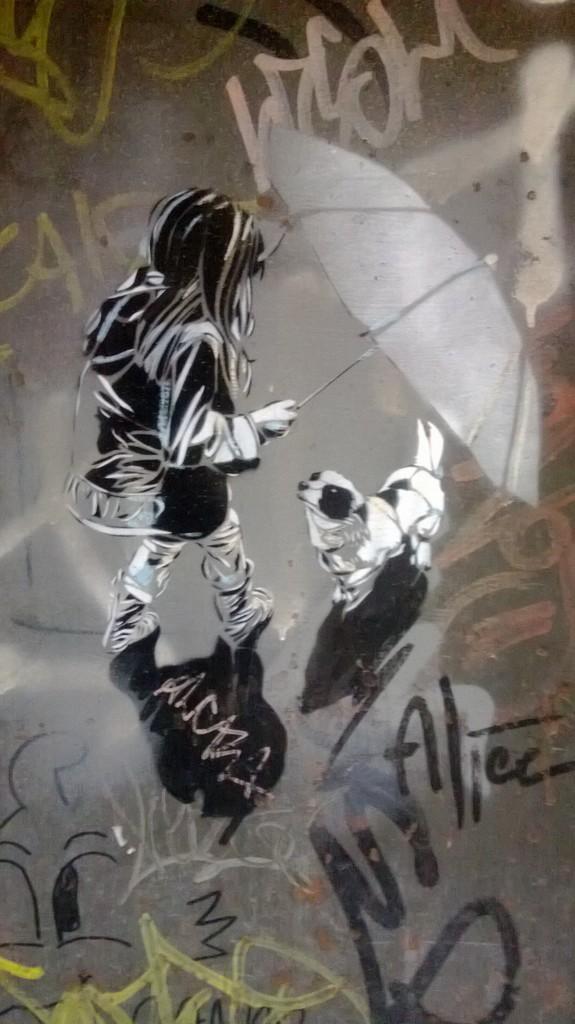Describe this image in one or two sentences. This picture consists of a graffiti. In the middle, we see the sketch of the girl who is holding an umbrella. Beside her, we see a dog. We see some text written on the wall. 